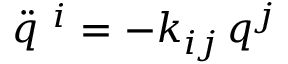Convert formula to latex. <formula><loc_0><loc_0><loc_500><loc_500>\ddot { q } ^ { \ i } = - k _ { i j } \, q ^ { j }</formula> 